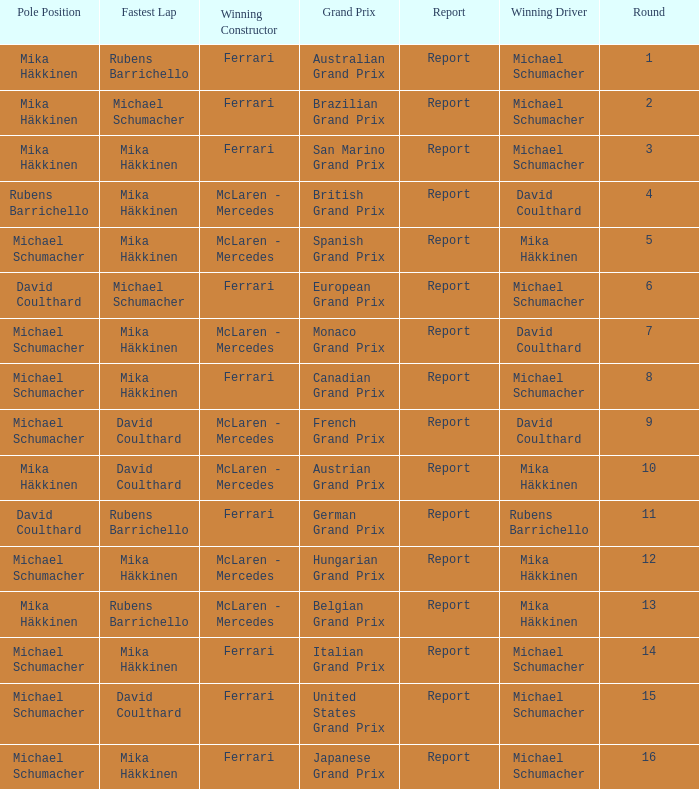What was the report of the Belgian Grand Prix? Report. I'm looking to parse the entire table for insights. Could you assist me with that? {'header': ['Pole Position', 'Fastest Lap', 'Winning Constructor', 'Grand Prix', 'Report', 'Winning Driver', 'Round'], 'rows': [['Mika Häkkinen', 'Rubens Barrichello', 'Ferrari', 'Australian Grand Prix', 'Report', 'Michael Schumacher', '1'], ['Mika Häkkinen', 'Michael Schumacher', 'Ferrari', 'Brazilian Grand Prix', 'Report', 'Michael Schumacher', '2'], ['Mika Häkkinen', 'Mika Häkkinen', 'Ferrari', 'San Marino Grand Prix', 'Report', 'Michael Schumacher', '3'], ['Rubens Barrichello', 'Mika Häkkinen', 'McLaren - Mercedes', 'British Grand Prix', 'Report', 'David Coulthard', '4'], ['Michael Schumacher', 'Mika Häkkinen', 'McLaren - Mercedes', 'Spanish Grand Prix', 'Report', 'Mika Häkkinen', '5'], ['David Coulthard', 'Michael Schumacher', 'Ferrari', 'European Grand Prix', 'Report', 'Michael Schumacher', '6'], ['Michael Schumacher', 'Mika Häkkinen', 'McLaren - Mercedes', 'Monaco Grand Prix', 'Report', 'David Coulthard', '7'], ['Michael Schumacher', 'Mika Häkkinen', 'Ferrari', 'Canadian Grand Prix', 'Report', 'Michael Schumacher', '8'], ['Michael Schumacher', 'David Coulthard', 'McLaren - Mercedes', 'French Grand Prix', 'Report', 'David Coulthard', '9'], ['Mika Häkkinen', 'David Coulthard', 'McLaren - Mercedes', 'Austrian Grand Prix', 'Report', 'Mika Häkkinen', '10'], ['David Coulthard', 'Rubens Barrichello', 'Ferrari', 'German Grand Prix', 'Report', 'Rubens Barrichello', '11'], ['Michael Schumacher', 'Mika Häkkinen', 'McLaren - Mercedes', 'Hungarian Grand Prix', 'Report', 'Mika Häkkinen', '12'], ['Mika Häkkinen', 'Rubens Barrichello', 'McLaren - Mercedes', 'Belgian Grand Prix', 'Report', 'Mika Häkkinen', '13'], ['Michael Schumacher', 'Mika Häkkinen', 'Ferrari', 'Italian Grand Prix', 'Report', 'Michael Schumacher', '14'], ['Michael Schumacher', 'David Coulthard', 'Ferrari', 'United States Grand Prix', 'Report', 'Michael Schumacher', '15'], ['Michael Schumacher', 'Mika Häkkinen', 'Ferrari', 'Japanese Grand Prix', 'Report', 'Michael Schumacher', '16']]} 